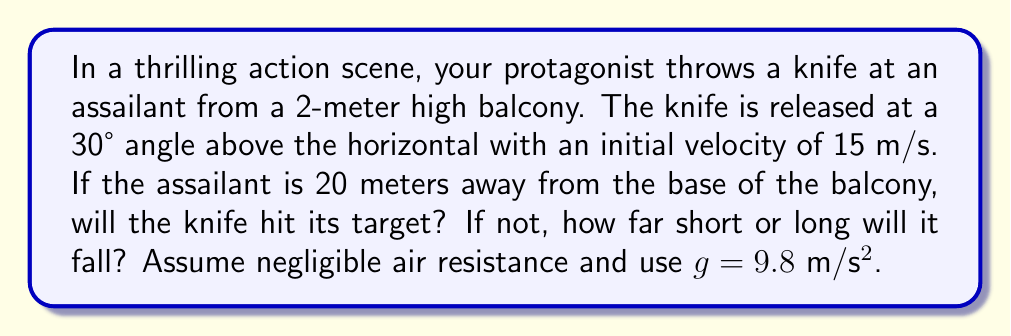Could you help me with this problem? To solve this problem, we'll use the equations of projectile motion:

1) Horizontal motion: $x = v_0 \cos(\theta) t$
2) Vertical motion: $y = h_0 + v_0 \sin(\theta) t - \frac{1}{2}gt^2$

Where:
$v_0 = 15$ m/s (initial velocity)
$\theta = 30°$ (angle above horizontal)
$h_0 = 2$ m (initial height)
$g = 9.8$ m/s² (acceleration due to gravity)

Step 1: Calculate the time of flight
We need to find when y = 0 (knife hits the ground):

$0 = 2 + 15 \sin(30°) t - \frac{1}{2}(9.8)t^2$

Solving this quadratic equation:

$t = \frac{15 \sin(30°) + \sqrt{(15 \sin(30°))^2 + 4(\frac{1}{2})(9.8)(2)}}{9.8} \approx 1.59$ s

Step 2: Calculate the horizontal distance traveled
Using the horizontal motion equation:

$x = 15 \cos(30°) (1.59) \approx 20.65$ m

Step 3: Compare with target distance
The knife will travel 20.65 m horizontally, which is 0.65 m beyond the 20 m target.
Answer: The knife will overshoot the target by 0.65 m. 